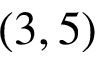<formula> <loc_0><loc_0><loc_500><loc_500>( 3 , 5 )</formula> 